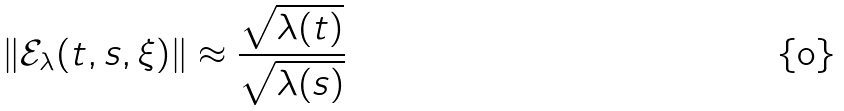Convert formula to latex. <formula><loc_0><loc_0><loc_500><loc_500>\| \mathcal { E } _ { \lambda } ( t , s , \xi ) \| \approx \frac { \sqrt { \lambda ( t ) } } { \sqrt { \lambda ( s ) } }</formula> 